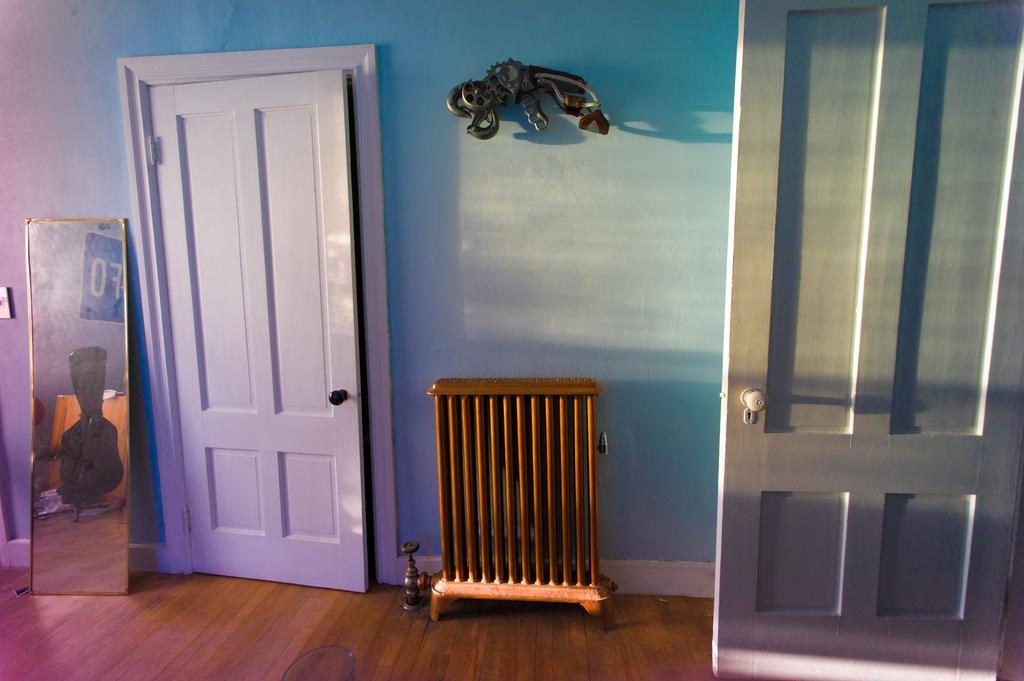Can you describe this image briefly? This picture describes about inside view of a room, in this we can find few doors and a mirror. 